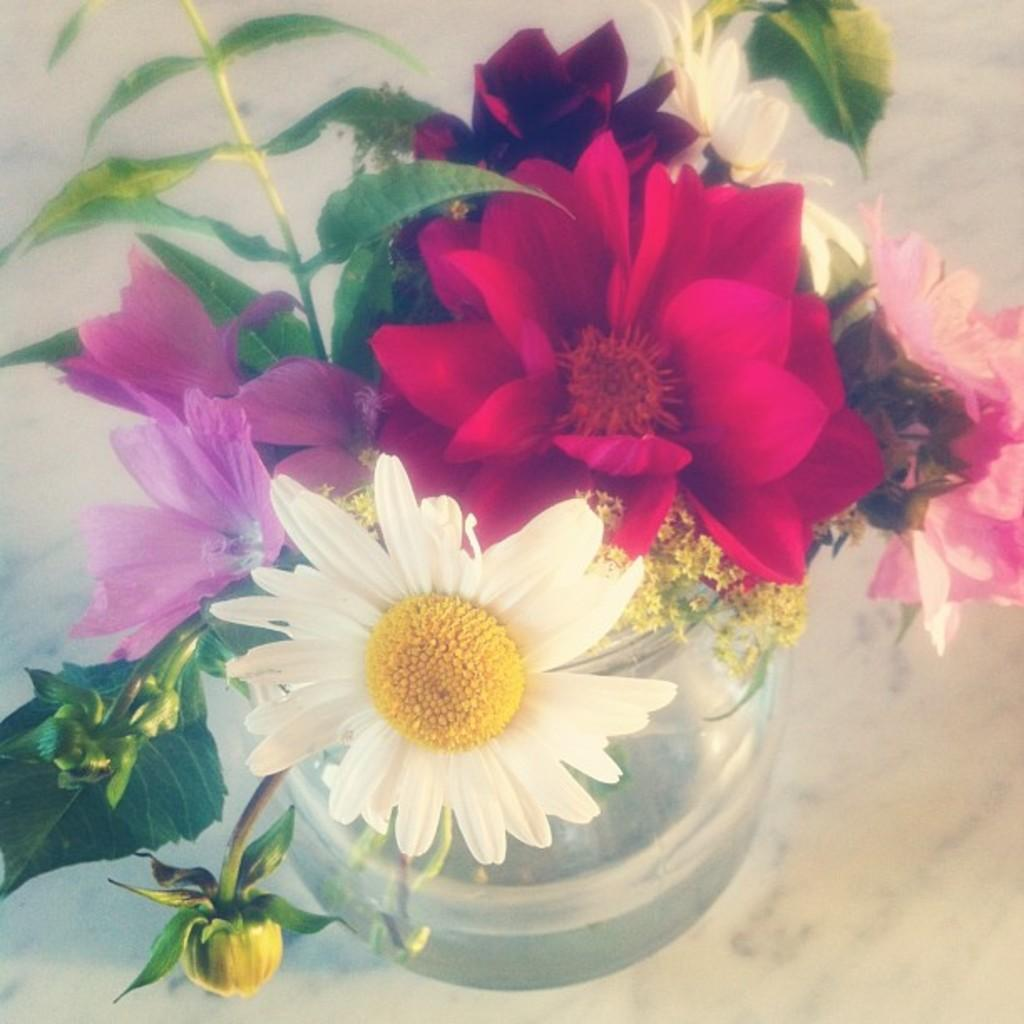What is located in the center of the image? There is a flower pot in the center of the image. What can be seen in the background of the image? There is a floor visible in the background of the image. How many stars can be seen in the image? There are no stars visible in the image. What type of cream is being used in the image? There is no cream present in the image. 